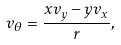<formula> <loc_0><loc_0><loc_500><loc_500>v _ { \theta } = \frac { x v _ { y } - y v _ { x } } { r } ,</formula> 